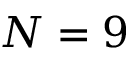<formula> <loc_0><loc_0><loc_500><loc_500>N = 9</formula> 